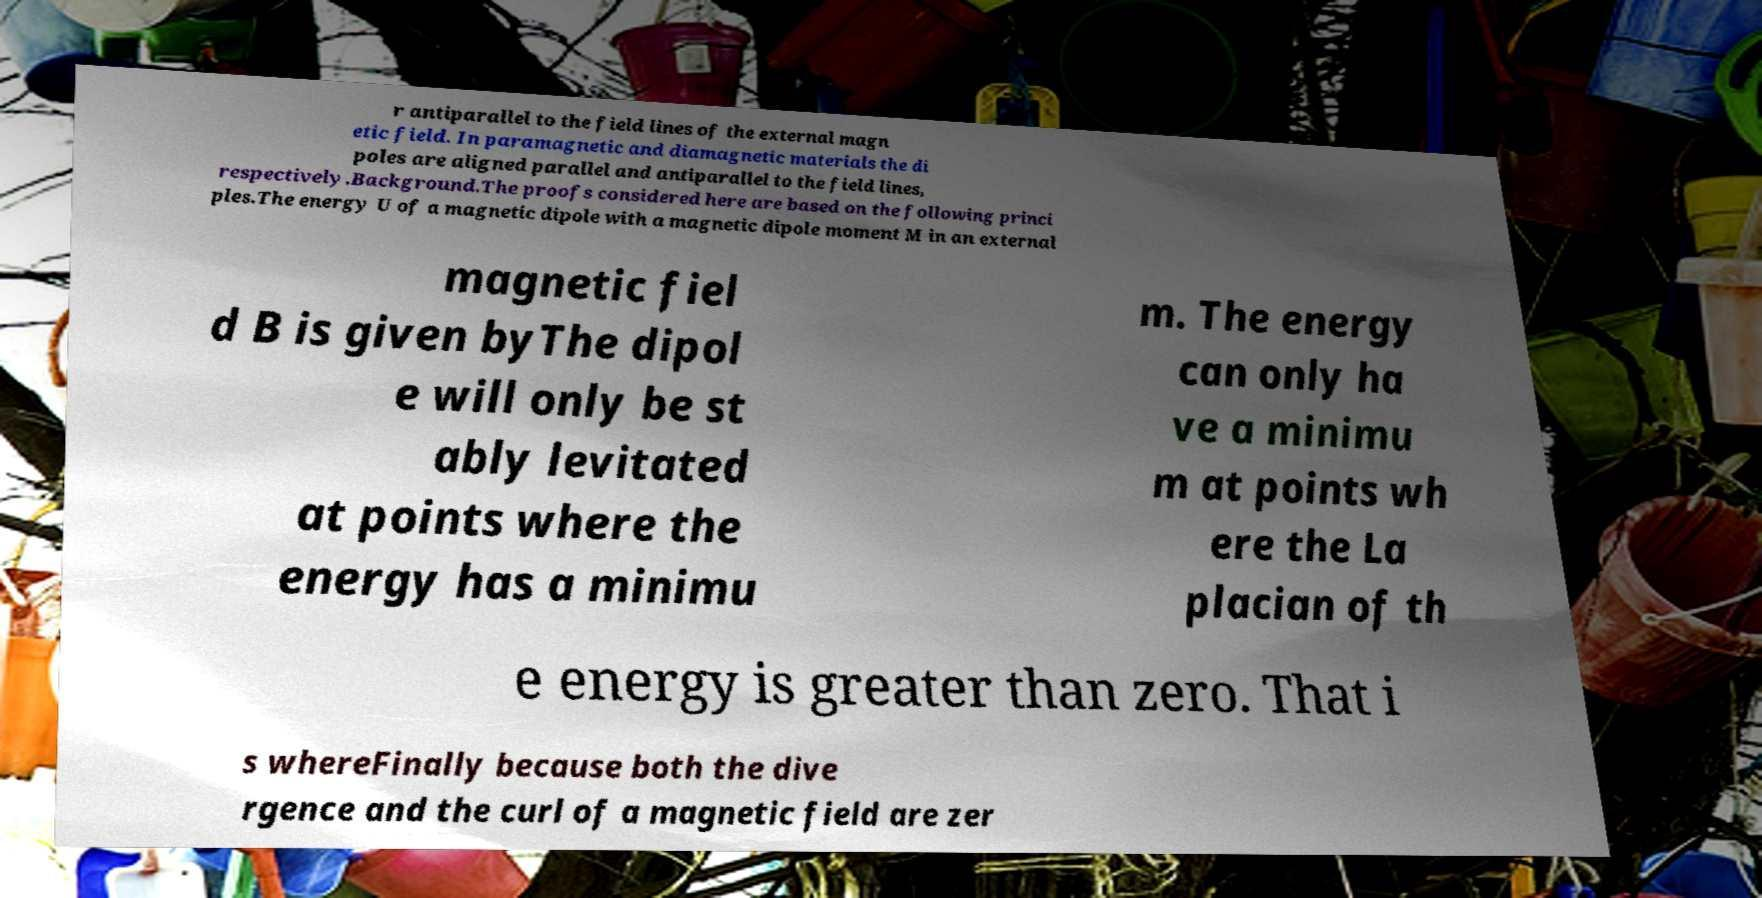What messages or text are displayed in this image? I need them in a readable, typed format. r antiparallel to the field lines of the external magn etic field. In paramagnetic and diamagnetic materials the di poles are aligned parallel and antiparallel to the field lines, respectively.Background.The proofs considered here are based on the following princi ples.The energy U of a magnetic dipole with a magnetic dipole moment M in an external magnetic fiel d B is given byThe dipol e will only be st ably levitated at points where the energy has a minimu m. The energy can only ha ve a minimu m at points wh ere the La placian of th e energy is greater than zero. That i s whereFinally because both the dive rgence and the curl of a magnetic field are zer 